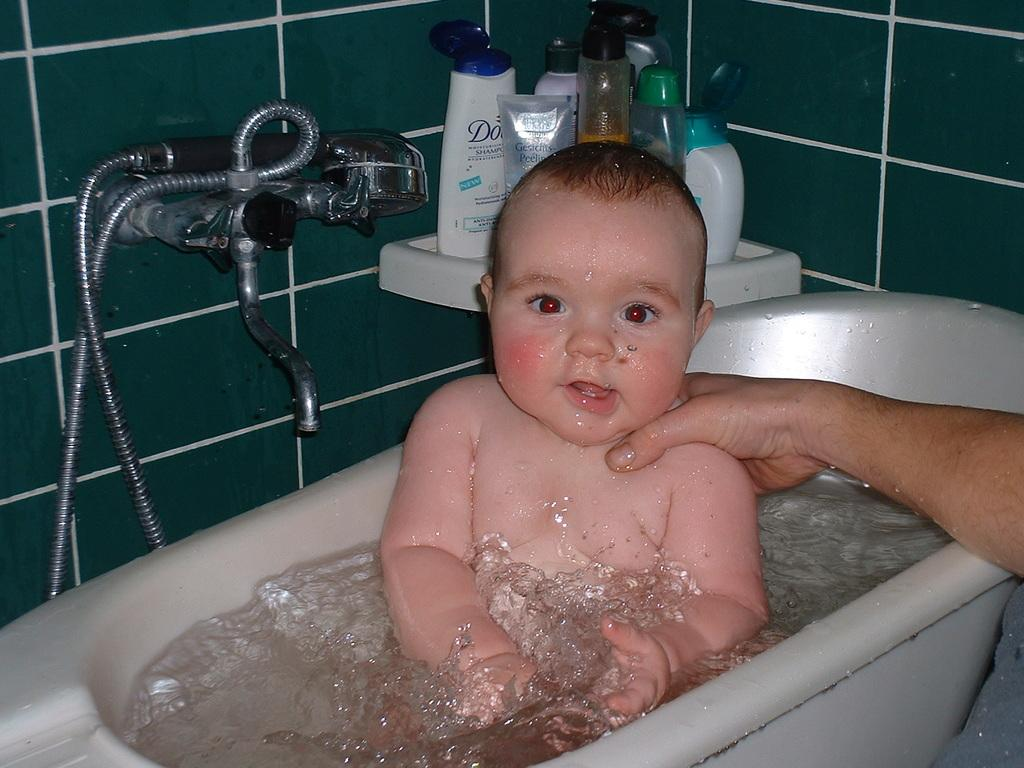What is the main subject of the image? There is a child in the bathtub. Can you describe any other elements in the image? A person's hand is visible, and there are shampoo bottles in the image. What type of material is used for the wall in the image? Tiles are present on the wall. What is the purpose of the visible object with a hose attached to it? A hand shower is visible in the image. What type of tray is being used to hold the jail in the image? There is no tray or jail present in the image. 